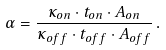Convert formula to latex. <formula><loc_0><loc_0><loc_500><loc_500>\alpha = \frac { \kappa _ { o n } \cdot t _ { o n } \cdot A _ { o n } } { \kappa _ { o f f } \cdot t _ { o f f } \cdot A _ { o f f } } \, .</formula> 